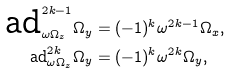Convert formula to latex. <formula><loc_0><loc_0><loc_500><loc_500>\text {ad} _ { \omega \Omega _ { z } } ^ { 2 k - 1 } \Omega _ { y } & = ( - 1 ) ^ { k } \omega ^ { 2 k - 1 } \Omega _ { x } , \\ \text {ad} _ { \omega \Omega _ { z } } ^ { 2 k } \Omega _ { y } & = ( - 1 ) ^ { k } \omega ^ { 2 k } \Omega _ { y } ,</formula> 